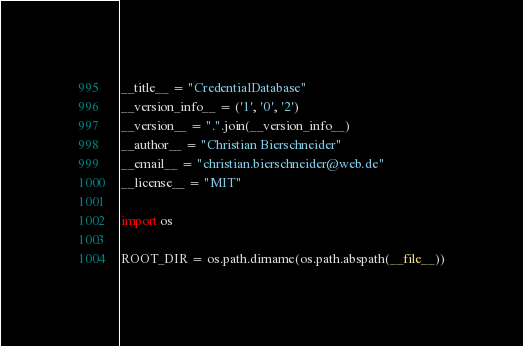Convert code to text. <code><loc_0><loc_0><loc_500><loc_500><_Python_>__title__ = "CredentialDatabase"
__version_info__ = ('1', '0', '2')
__version__ = ".".join(__version_info__)
__author__ = "Christian Bierschneider"
__email__ = "christian.bierschneider@web.de"
__license__ = "MIT"

import os

ROOT_DIR = os.path.dirname(os.path.abspath(__file__))
</code> 